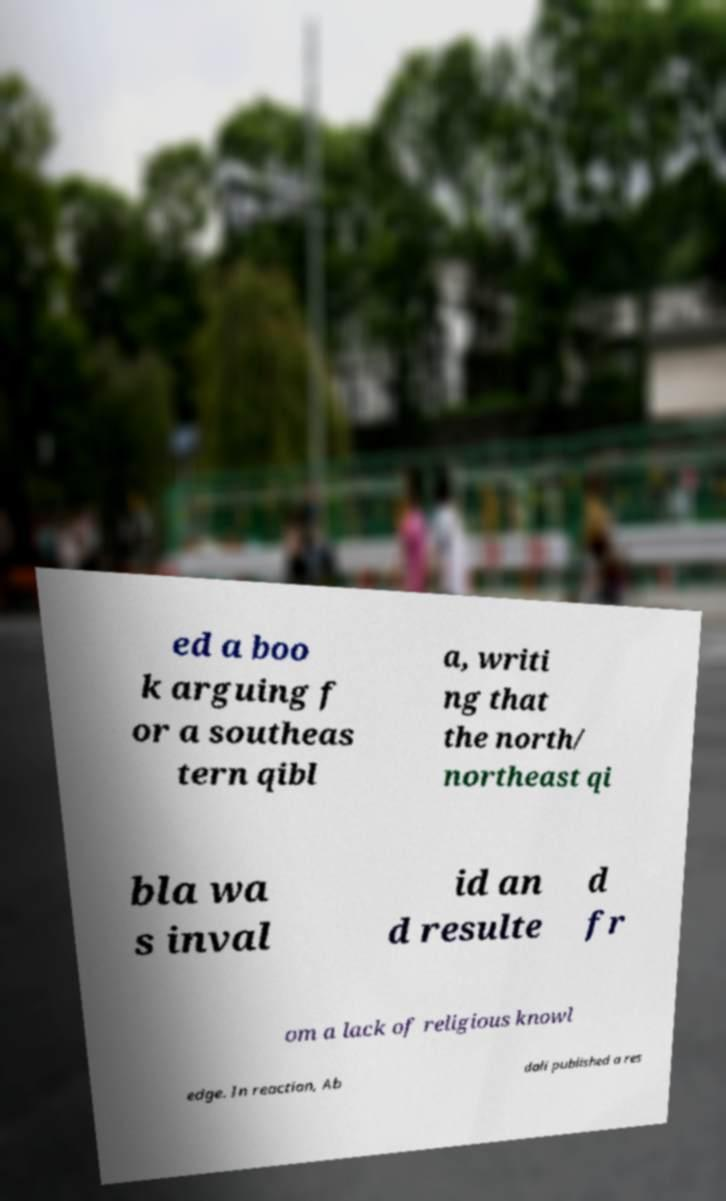Please identify and transcribe the text found in this image. ed a boo k arguing f or a southeas tern qibl a, writi ng that the north/ northeast qi bla wa s inval id an d resulte d fr om a lack of religious knowl edge. In reaction, Ab dali published a res 